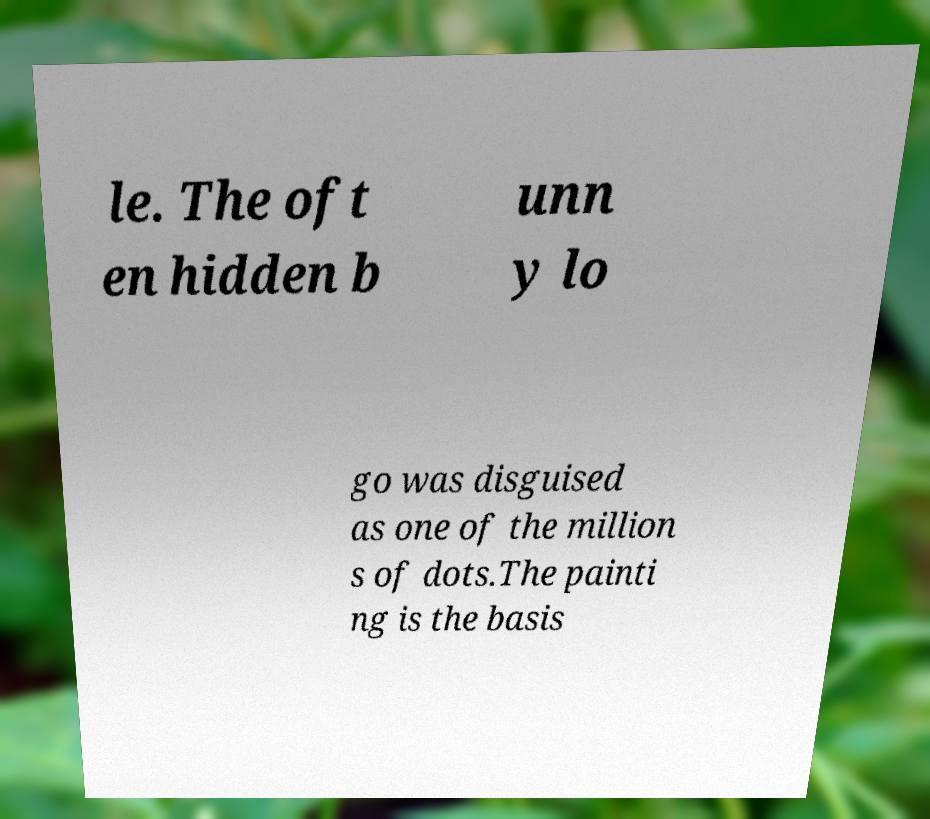Could you extract and type out the text from this image? le. The oft en hidden b unn y lo go was disguised as one of the million s of dots.The painti ng is the basis 